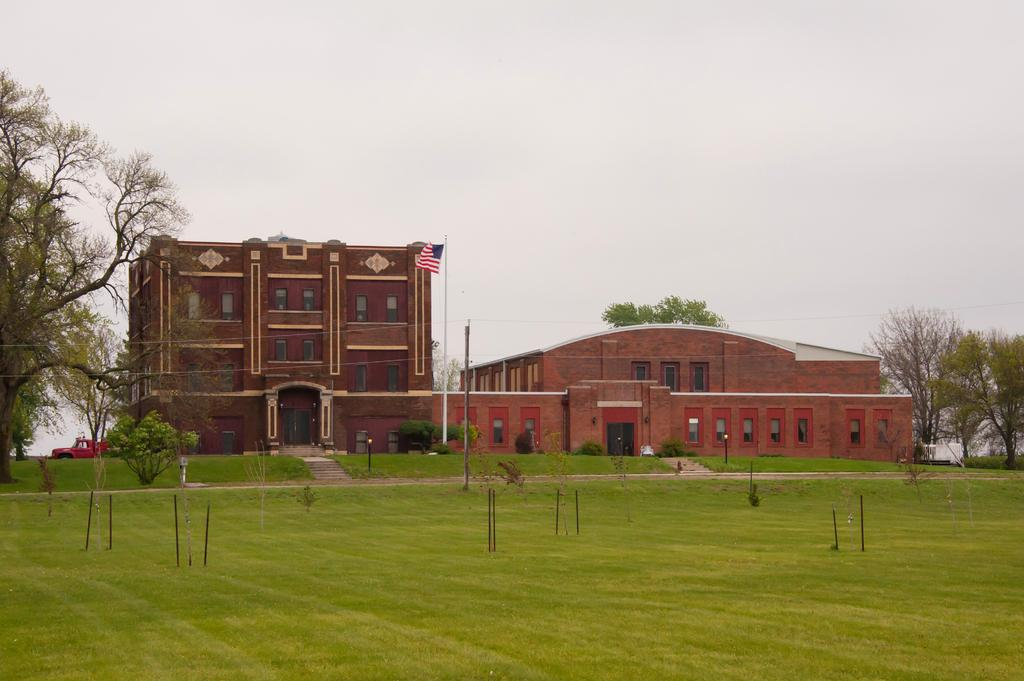What type of vegetation can be seen in the image? There is grass in the image. What else can be seen in the image besides grass? There are trees, poles, buildings, a flag, and a truck in the image. What is the purpose of the poles in the image? The purpose of the poles is not specified in the image, but they could be for supporting wires or signs. What is the flag attached to in the image? The flag is attached to a pole in the image. What type of crime is being committed in the image? There is no indication of any crime being committed in the image. What is the zephyr doing in the image? There is no zephyr present in the image; it is a term used to describe a gentle breeze, which cannot be seen in a photograph. 